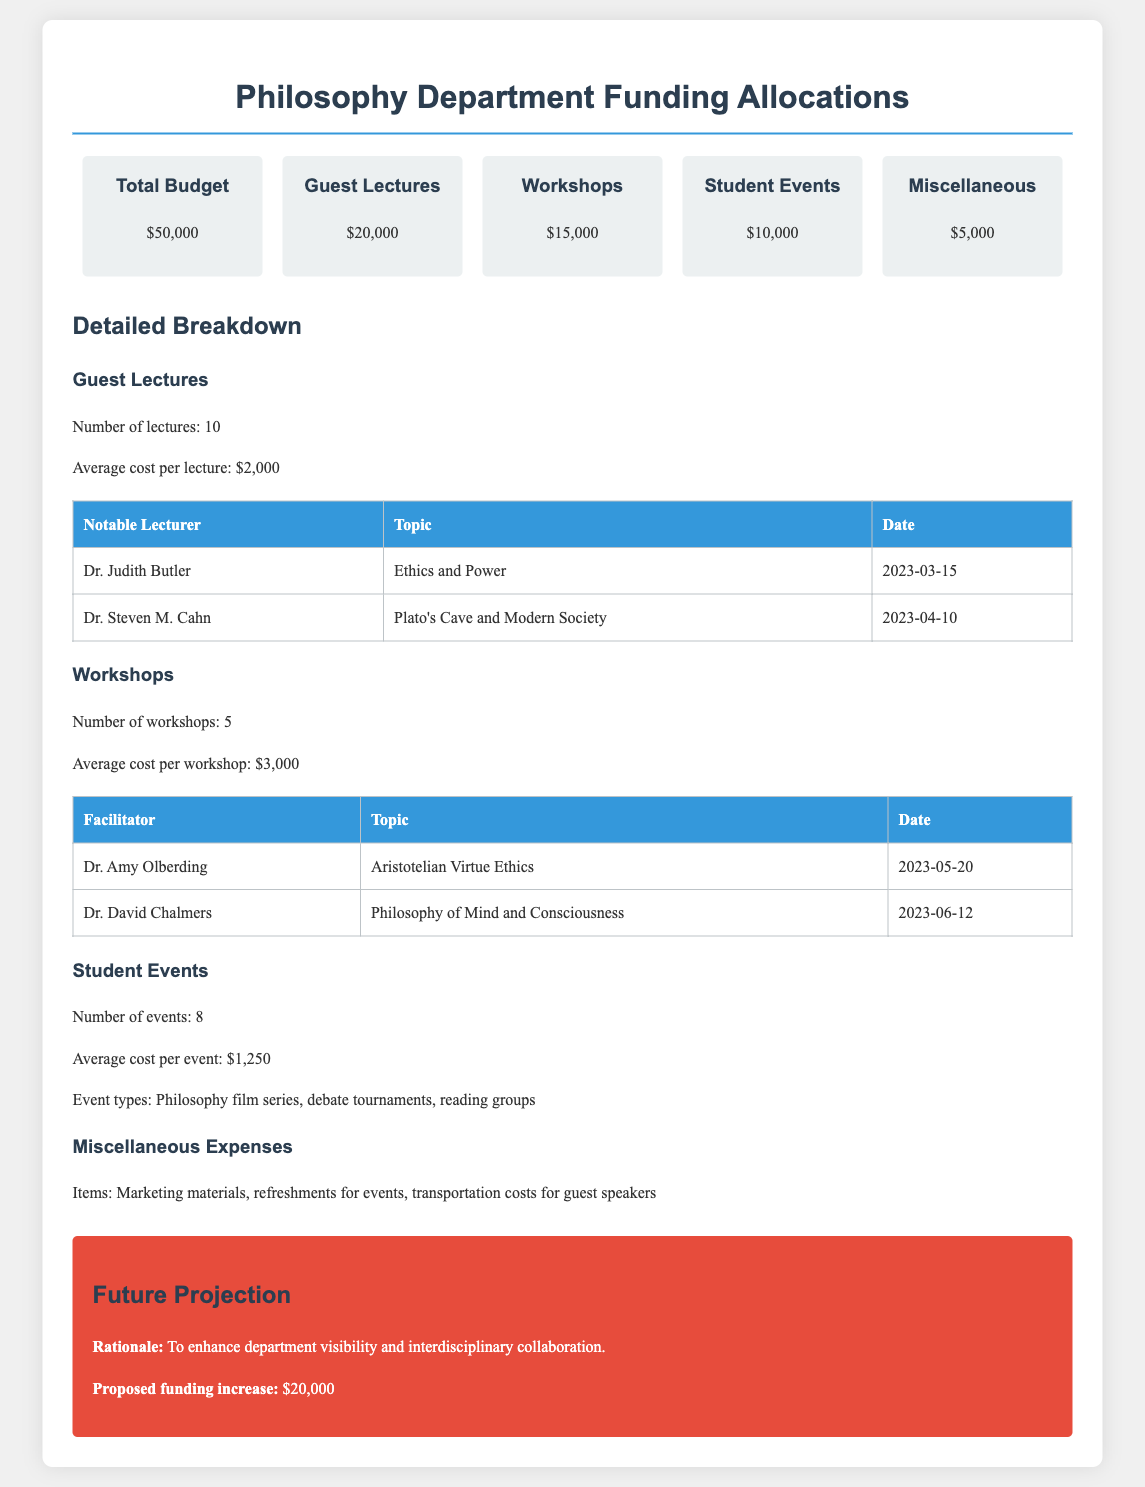What is the total budget for the Philosophy Department? The total budget is a cumulative amount designated for the Department's activities, which is $50,000.
Answer: $50,000 How much is allocated for guest lectures? The allocation for guest lectures is specified for funding events featuring invited speakers, which is $20,000.
Answer: $20,000 How many workshops are planned? The total number of workshops is mentioned explicitly in the document, which states there are 5 workshops planned.
Answer: 5 Who is the facilitator for the workshop on "Aristotelian Virtue Ethics"? The document lists facilitators for workshops, with Dr. Amy Olberding specifically facilitating this workshop.
Answer: Dr. Amy Olberding What is the average cost per student event? The document provides the average cost for student events, which is stated as $1,250.
Answer: $1,250 What is the total allocation for student events and workshops combined? This requires summing the allocations for both categories from the budget, which totals $15,000 for workshops and $10,000 for student events, resulting in $25,000.
Answer: $25,000 How many notable lecturers are mentioned in the document? The document includes a count of specific notable lecturers, which lists 2 lecturers.
Answer: 2 What justification is provided for the future funding increase? The document outlines the rationale for the future funding increase, emphasizing enhancement of department visibility and interdisciplinary collaboration.
Answer: Enhance department visibility What miscellaneous items are mentioned in the expenses? The document specifies various miscellaneous expenses categorized as items like marketing materials, refreshments for events, and transportation costs for guest speakers.
Answer: Marketing materials, refreshments, transportation costs 